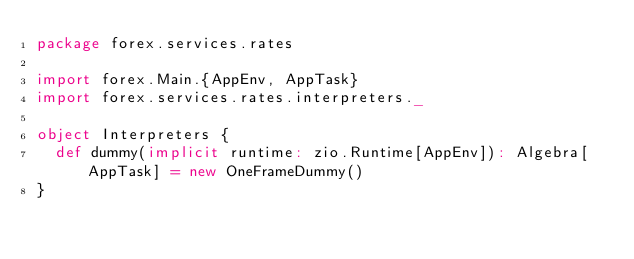<code> <loc_0><loc_0><loc_500><loc_500><_Scala_>package forex.services.rates

import forex.Main.{AppEnv, AppTask}
import forex.services.rates.interpreters._

object Interpreters {
  def dummy(implicit runtime: zio.Runtime[AppEnv]): Algebra[AppTask] = new OneFrameDummy()
}
</code> 